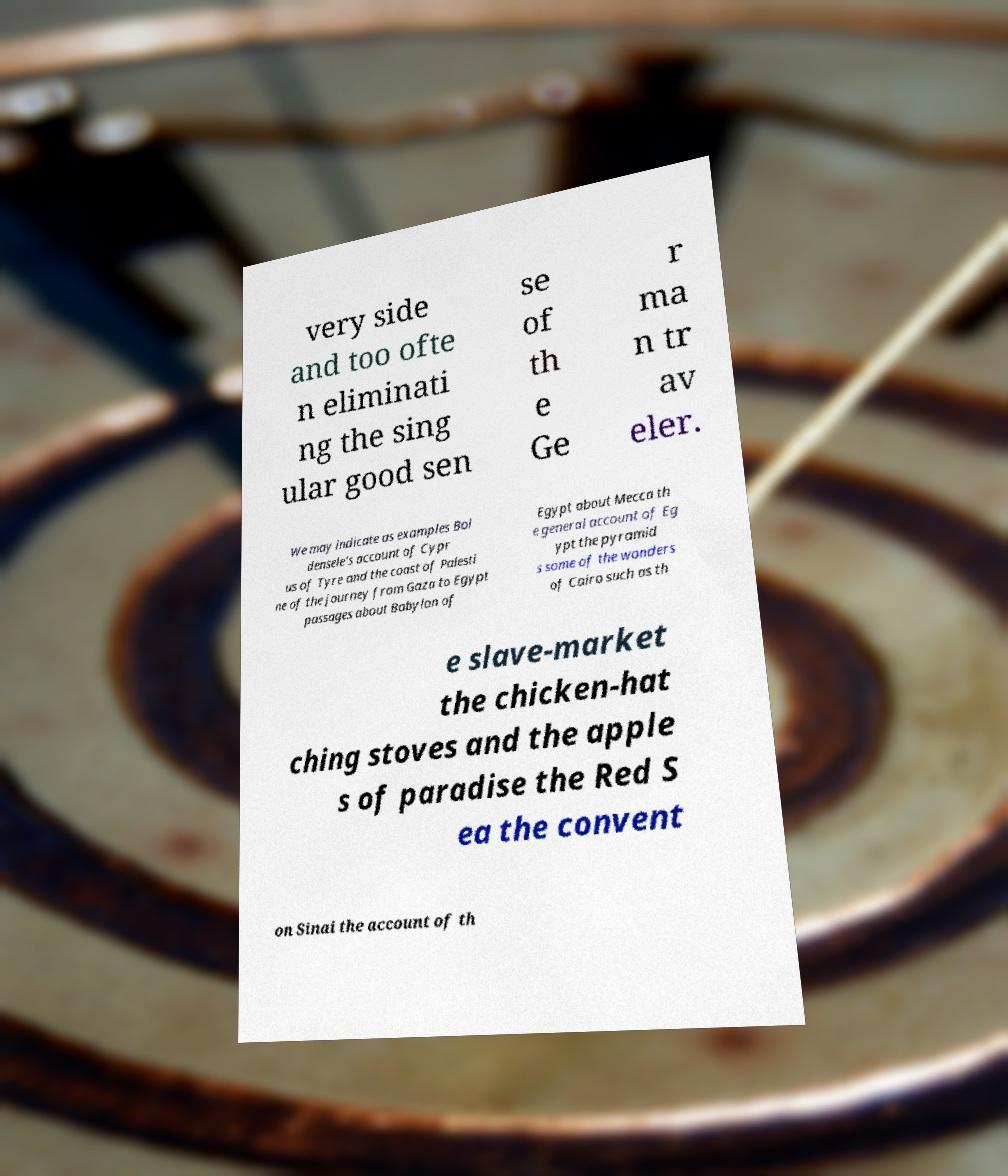Please identify and transcribe the text found in this image. very side and too ofte n eliminati ng the sing ular good sen se of th e Ge r ma n tr av eler. We may indicate as examples Bol densele's account of Cypr us of Tyre and the coast of Palesti ne of the journey from Gaza to Egypt passages about Babylon of Egypt about Mecca th e general account of Eg ypt the pyramid s some of the wonders of Cairo such as th e slave-market the chicken-hat ching stoves and the apple s of paradise the Red S ea the convent on Sinai the account of th 